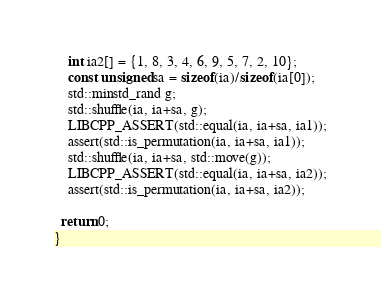Convert code to text. <code><loc_0><loc_0><loc_500><loc_500><_C++_>    int ia2[] = {1, 8, 3, 4, 6, 9, 5, 7, 2, 10};
    const unsigned sa = sizeof(ia)/sizeof(ia[0]);
    std::minstd_rand g;
    std::shuffle(ia, ia+sa, g);
    LIBCPP_ASSERT(std::equal(ia, ia+sa, ia1));
    assert(std::is_permutation(ia, ia+sa, ia1));
    std::shuffle(ia, ia+sa, std::move(g));
    LIBCPP_ASSERT(std::equal(ia, ia+sa, ia2));
    assert(std::is_permutation(ia, ia+sa, ia2));

  return 0;
}
</code> 